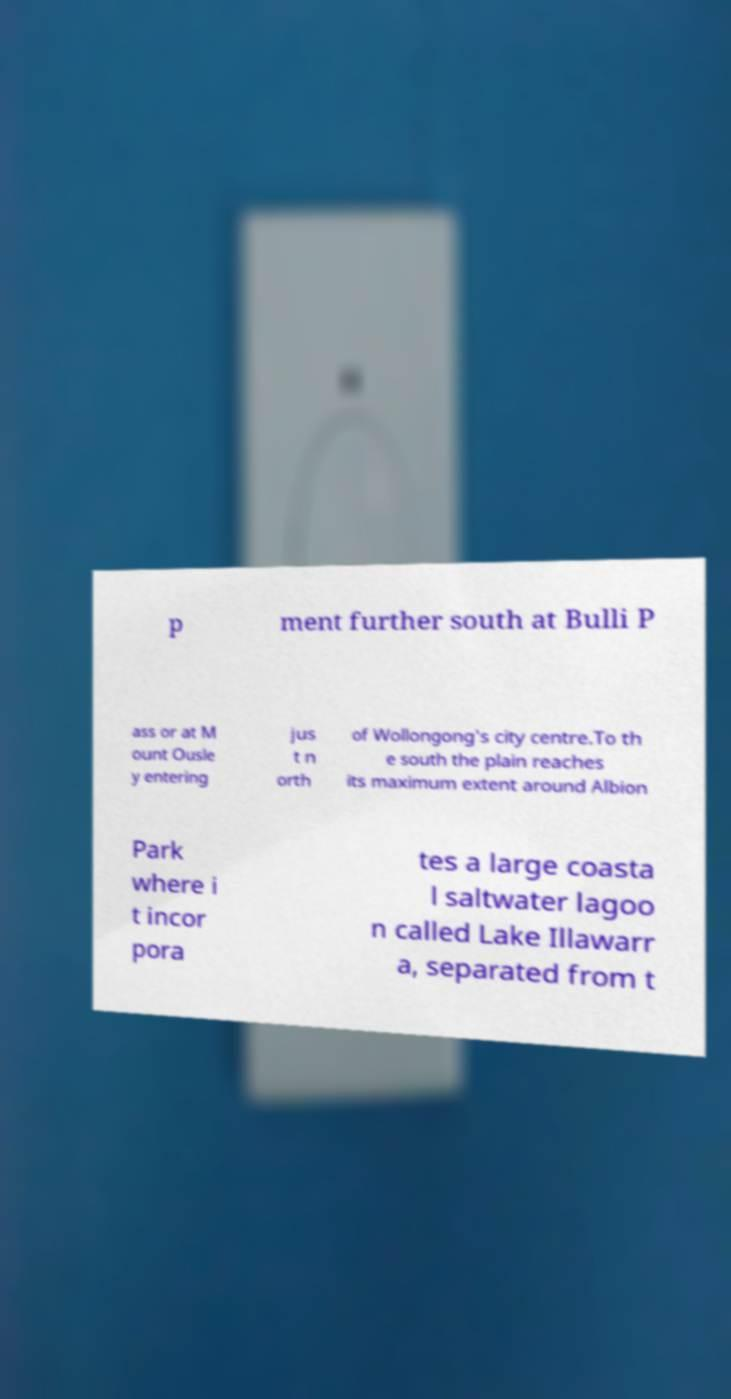Could you extract and type out the text from this image? p ment further south at Bulli P ass or at M ount Ousle y entering jus t n orth of Wollongong's city centre.To th e south the plain reaches its maximum extent around Albion Park where i t incor pora tes a large coasta l saltwater lagoo n called Lake Illawarr a, separated from t 